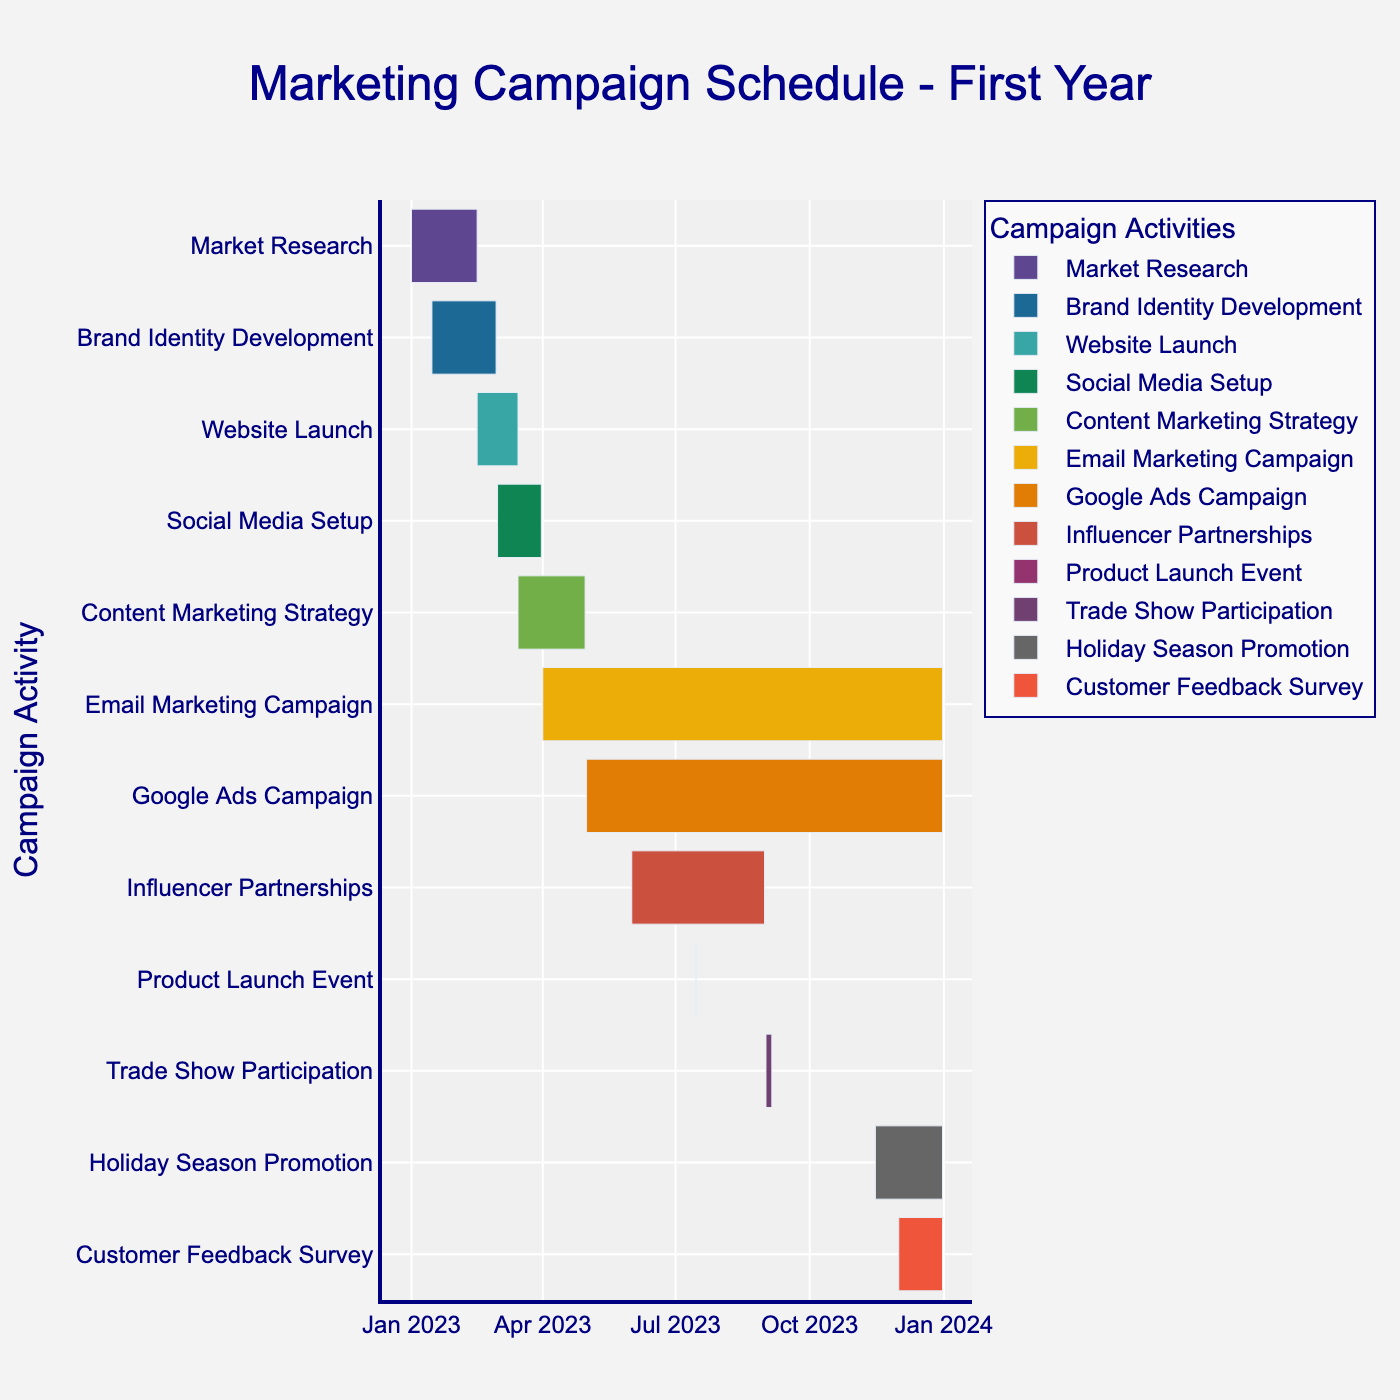What is the title of the Gantt chart? The title of the Gantt chart is located at the top and is typically one of the first elements visible to the viewer.
Answer: Marketing Campaign Schedule - First Year How many tasks are listed in the Gantt chart? Count the number of distinct tasks along the y-axis. Each task is labeled on the y-axis.
Answer: 12 When does the "Social Media Setup" activity start and end? Locate the "Social Media Setup" task on the y-axis and read the start and end dates from the corresponding bar on the Gantt chart.
Answer: Start: March 1, 2023; End: March 31, 2023 Which task has the shortest duration? Compare the lengths of all the bars representing each task to determine the shortest. "Product Launch Event" is the shortest task as it's a single-day event.
Answer: Product Launch Event How long is the "Email Marketing Campaign" in days? Calculate the number of days between the start and end dates: from April 1, 2023 to December 31, 2023.
Answer: 275 days Which tasks overlap with the "Content Marketing Strategy"? Determine the period of "Content Marketing Strategy" and list the tasks that have their time bars within this period. It runs from March 15, 2023, to April 30, 2023.
Answer: Social Media Setup, Email Marketing Campaign What is the time span between the end of "Brand Identity Development" and the start of "Website Launch"? Calculate the number of days from the end date of "Brand Identity Development" (February 28, 2023) to the start date of "Website Launch" (February 15, 2023). Note there seems to be an inconsistency to check as the end would normally be before the start.
Answer: Common understanding of no gap unless treated overlapping Which activities are scheduled to run during the end of the year (December 2023)? Identify tasks with bars extending into December 2023.
Answer: Email Marketing Campaign, Google Ads Campaign, Holiday Season Promotion, Customer Feedback Survey What is the duration of the "Google Ads Campaign"? Calculate the difference in days from the start date (May 1, 2023) to the end date (December 31, 2023).
Answer: 245 days Which promotional activities span more than half of the year? List the tasks with durations greater than 182 days (half of 365 days).
Answer: Email Marketing Campaign, Google Ads Campaign 